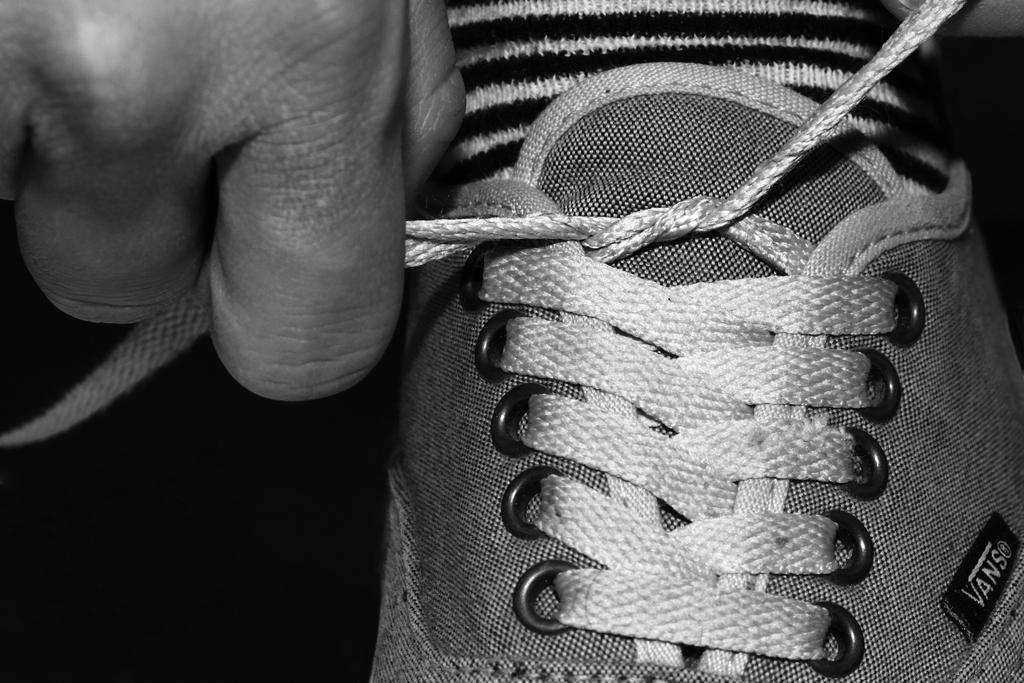What is the color scheme of the image? The image is black and white. What is the person's hand doing in the image? The person's hand is holding a shoelace in the image. What is the condition of the shoe in the image? There is a shoe without lace in the image. What type of clothing is present in the image? There is a pair of socks in the image. How would you describe the lighting in the image? The background of the image appears dark. How many hands are visible on the scale in the image? There is no scale present in the image, and therefore no hands can be seen on it. What type of sack is being used to store the shoelace in the image? There is no sack present in the image; the shoelace is being held by a person's hand. 